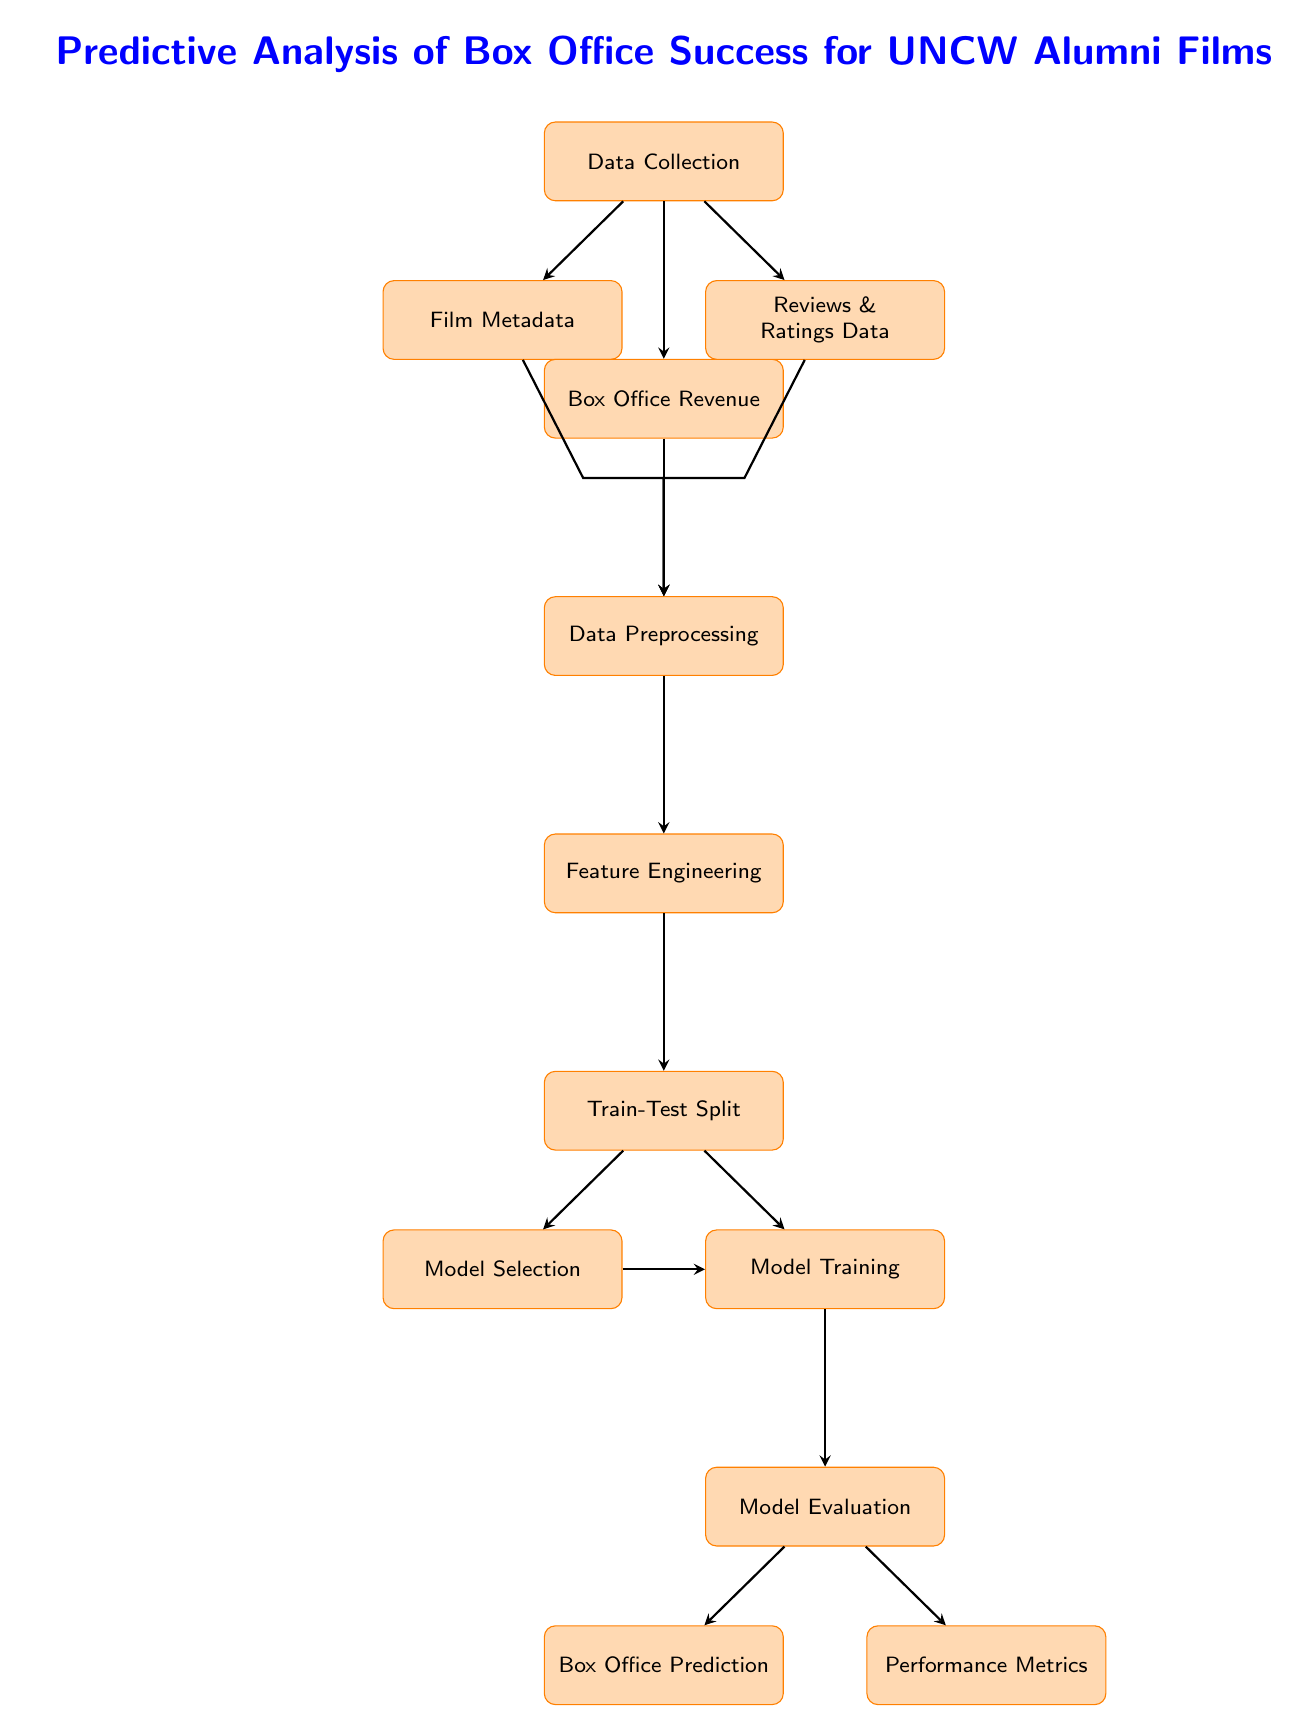What is the first step in the predictive analysis process? The diagram starts with the "Data Collection" node, which indicates that this is the initial step of the process before any other actions are taken.
Answer: Data Collection How many final outputs are there in this diagram? The diagram shows two final outputs coming out of the "Model Evaluation" node: "Box Office Prediction" and "Performance Metrics." Hence, there are two outputs.
Answer: Two Which node comes after "Feature Engineering"? After "Feature Engineering," the next node in the diagram is "Train-Test Split," which signifies that this step follows feature engineering in the process.
Answer: Train-Test Split What type of data is collected in the "Data Collection" step? The "Data Collection" step collects three types of data: "Film Metadata," "Box Office Revenue," and "Reviews & Ratings Data."
Answer: Three types Which node connects "Model Selection" and "Model Training"? The connection is made through "Train-Test Split," as it acts as a junction that leads both to "Model Selection" and "Model Training."
Answer: Train-Test Split What is the purpose of the "Performance Metrics" node? The "Performance Metrics" node serves to evaluate and present the effectiveness of the predictive model in quantifiable terms, summarizing the model's performance post-evaluation.
Answer: Model Evaluation summary What is the relationship between "Reviews & Ratings Data" and "Data Preprocessing"? "Reviews & Ratings Data" flows into "Data Preprocessing," indicating that this specific type of data undergoes preprocessing as part of the overall analysis before further steps.
Answer: Flow into Data Preprocessing What is indicated by the arrows in the diagram? The arrows represent the flow of data and the sequence of processes that need to be followed to analyze and predict box office success effectively.
Answer: Sequence of processes What is the output of the "Model Evaluation" node? The "Model Evaluation" node leads to two outputs, "Box Office Prediction" and "Performance Metrics," demonstrating the results derived from the evaluation stage.
Answer: Box Office Prediction and Performance Metrics 